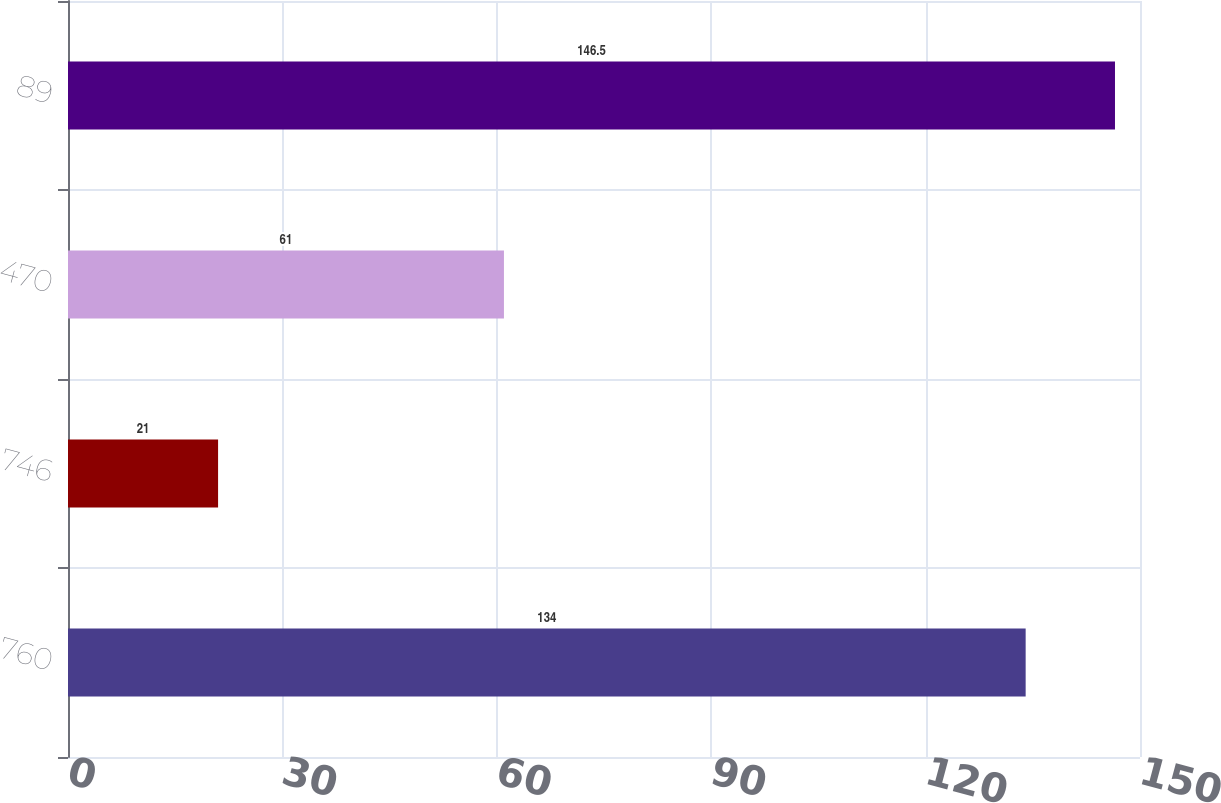Convert chart. <chart><loc_0><loc_0><loc_500><loc_500><bar_chart><fcel>760<fcel>746<fcel>470<fcel>89<nl><fcel>134<fcel>21<fcel>61<fcel>146.5<nl></chart> 